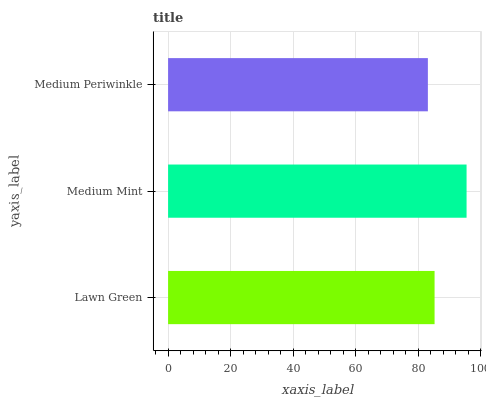Is Medium Periwinkle the minimum?
Answer yes or no. Yes. Is Medium Mint the maximum?
Answer yes or no. Yes. Is Medium Mint the minimum?
Answer yes or no. No. Is Medium Periwinkle the maximum?
Answer yes or no. No. Is Medium Mint greater than Medium Periwinkle?
Answer yes or no. Yes. Is Medium Periwinkle less than Medium Mint?
Answer yes or no. Yes. Is Medium Periwinkle greater than Medium Mint?
Answer yes or no. No. Is Medium Mint less than Medium Periwinkle?
Answer yes or no. No. Is Lawn Green the high median?
Answer yes or no. Yes. Is Lawn Green the low median?
Answer yes or no. Yes. Is Medium Periwinkle the high median?
Answer yes or no. No. Is Medium Mint the low median?
Answer yes or no. No. 